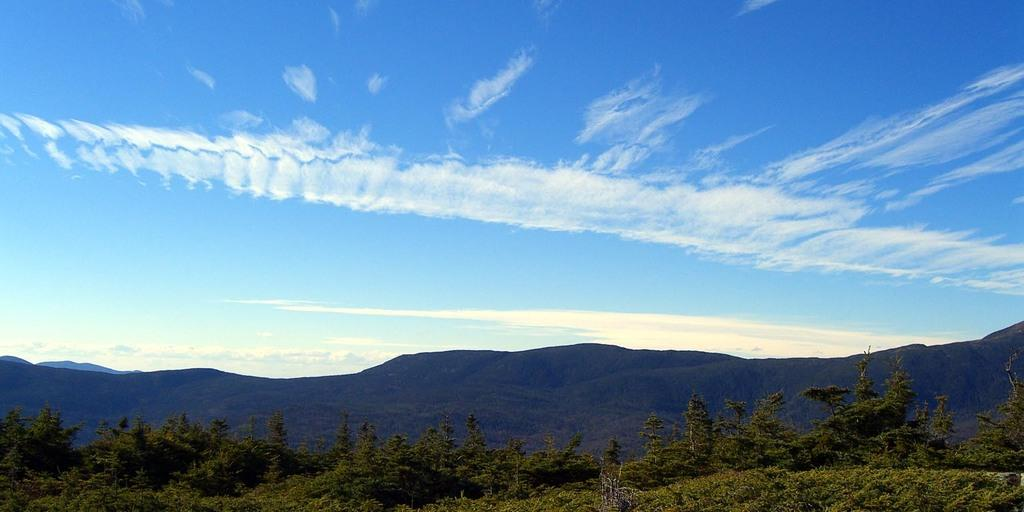What type of vegetation is present at the bottom of the image? There are trees in the bottom of the image. What type of natural formation can be seen in the background of the image? There are mountains in the background of the image. What is the condition of the sky in the image? The sky is cloudy at the top of the image. What is the preferred way of sorting hobbies for the trees in the image? There are no hobbies mentioned or associated with the trees in the image. 